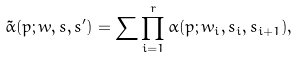Convert formula to latex. <formula><loc_0><loc_0><loc_500><loc_500>\tilde { \alpha } ( p ; w , s , s ^ { \prime } ) = \sum \prod _ { i = 1 } ^ { r } \alpha ( p ; w _ { i } , s _ { i } , s _ { i + 1 } ) ,</formula> 